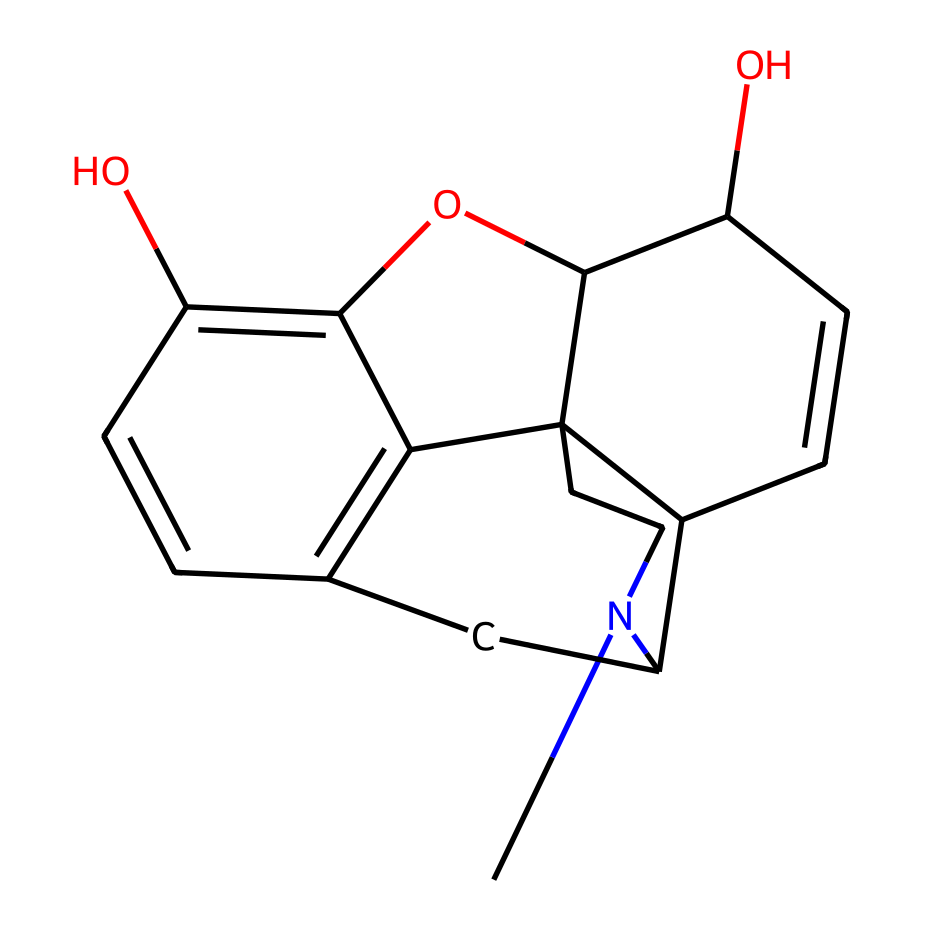What is the main functional group present in morphine? The presence of the hydroxyl (-OH) groups is significant in morphine's structure. Counting the number of -OH groups in the chemical structure determines the main functional group, which is hydroxyl.
Answer: hydroxyl How many rings are present in the morphine structure? By examining the structure, we can count the distinct cyclic components. In morphine, there are five rings interlinked together, confirming the complex structure typical of alkaloids.
Answer: five What type of compound is morphine classified as? Morphine, derived from opium poppies, is specifically an alkaloid, which is a type of nitrogen-containing organic compound. Its classification is based on its structural characteristics and biological activity.
Answer: alkaloid How many nitrogen atoms are present in morphine? Inspecting the SMILES representation reveals one nitrogen atom in the structure of morphine, which contributes to its classification as an alkaloid.
Answer: one What is the molecular formula of morphine based on its structure? Analyzing the number of each type of atom in the structure gives a total of 17 carbon, 19 hydrogen, 1 nitrogen, and 2 oxygen atoms, leading to the molecular formula C17H19NO2.
Answer: C17H19NO2 Which property makes morphine a potent pain reliever? The interaction of morphine with specific receptors in the brain is primarily due to its structural features, notably its ability to mimic natural neurotransmitters and bind effectively to mu-opioid receptors.
Answer: receptor binding What characteristic does the presence of the hydroxyl groups impart to morphine? The hydroxyl groups enhance morphine’s solubility in water and contribute to its pharmacological properties, particularly the ability to cross biological membranes and interact with cellular receptors.
Answer: solubility 